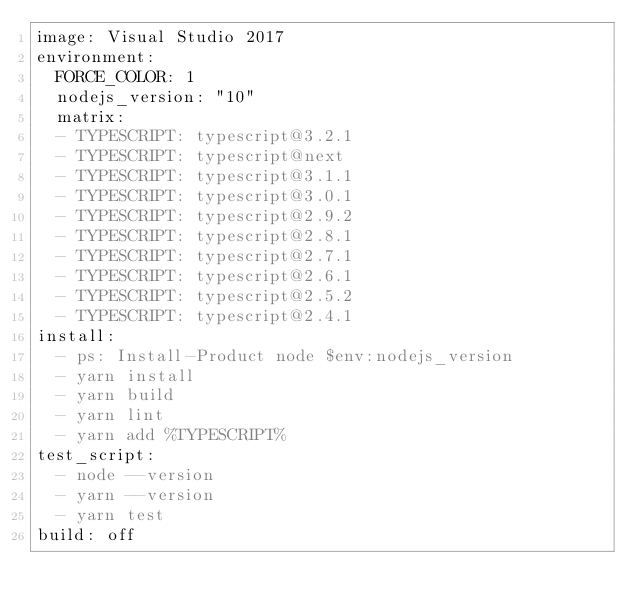Convert code to text. <code><loc_0><loc_0><loc_500><loc_500><_YAML_>image: Visual Studio 2017
environment:
  FORCE_COLOR: 1
  nodejs_version: "10"
  matrix:
  - TYPESCRIPT: typescript@3.2.1
  - TYPESCRIPT: typescript@next
  - TYPESCRIPT: typescript@3.1.1
  - TYPESCRIPT: typescript@3.0.1
  - TYPESCRIPT: typescript@2.9.2
  - TYPESCRIPT: typescript@2.8.1
  - TYPESCRIPT: typescript@2.7.1
  - TYPESCRIPT: typescript@2.6.1
  - TYPESCRIPT: typescript@2.5.2
  - TYPESCRIPT: typescript@2.4.1
install:
  - ps: Install-Product node $env:nodejs_version
  - yarn install
  - yarn build
  - yarn lint
  - yarn add %TYPESCRIPT%
test_script:
  - node --version
  - yarn --version
  - yarn test
build: off
</code> 